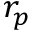<formula> <loc_0><loc_0><loc_500><loc_500>r _ { p }</formula> 